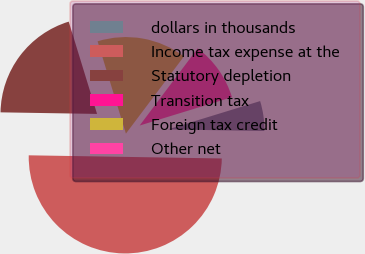<chart> <loc_0><loc_0><loc_500><loc_500><pie_chart><fcel>dollars in thousands<fcel>Income tax expense at the<fcel>Statutory depletion<fcel>Transition tax<fcel>Foreign tax credit<fcel>Other net<nl><fcel>5.0%<fcel>50.0%<fcel>20.0%<fcel>0.0%<fcel>15.0%<fcel>10.0%<nl></chart> 